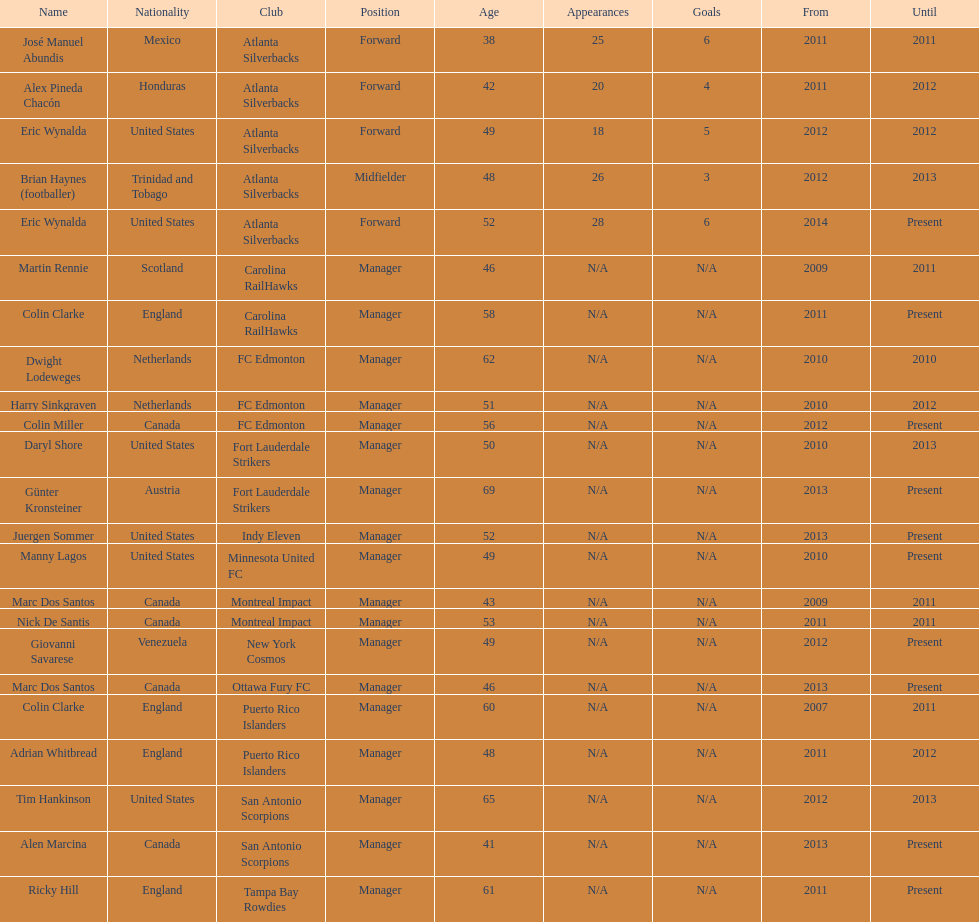How many coaches have coached from america? 6. 